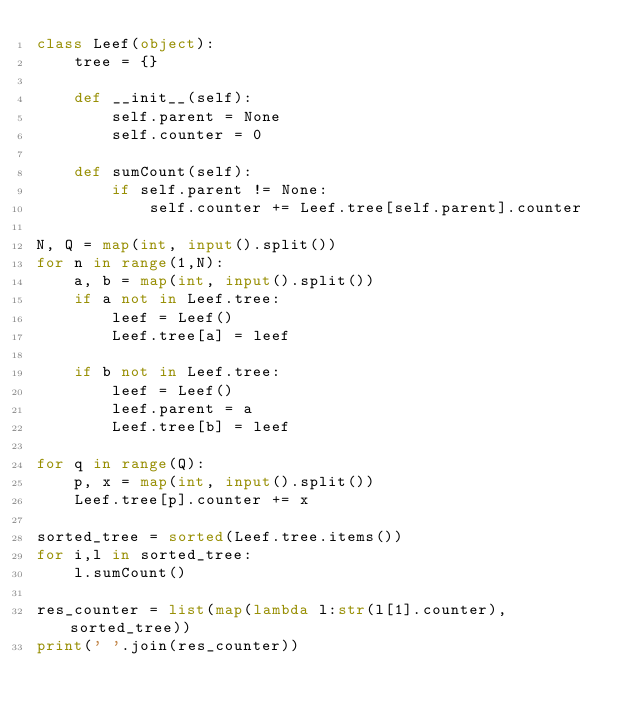<code> <loc_0><loc_0><loc_500><loc_500><_Python_>class Leef(object):
	tree = {}

	def __init__(self):
		self.parent = None
		self.counter = 0

	def sumCount(self):
		if self.parent != None:
			self.counter += Leef.tree[self.parent].counter

N, Q = map(int, input().split())
for n in range(1,N):
	a, b = map(int, input().split())
	if a not in Leef.tree:
		leef = Leef()
		Leef.tree[a] = leef

	if b not in Leef.tree:
		leef = Leef()
		leef.parent = a
		Leef.tree[b] = leef

for q in range(Q):
	p, x = map(int, input().split())
	Leef.tree[p].counter += x

sorted_tree = sorted(Leef.tree.items())
for i,l in sorted_tree:
	l.sumCount()

res_counter = list(map(lambda l:str(l[1].counter), sorted_tree))
print(' '.join(res_counter))</code> 